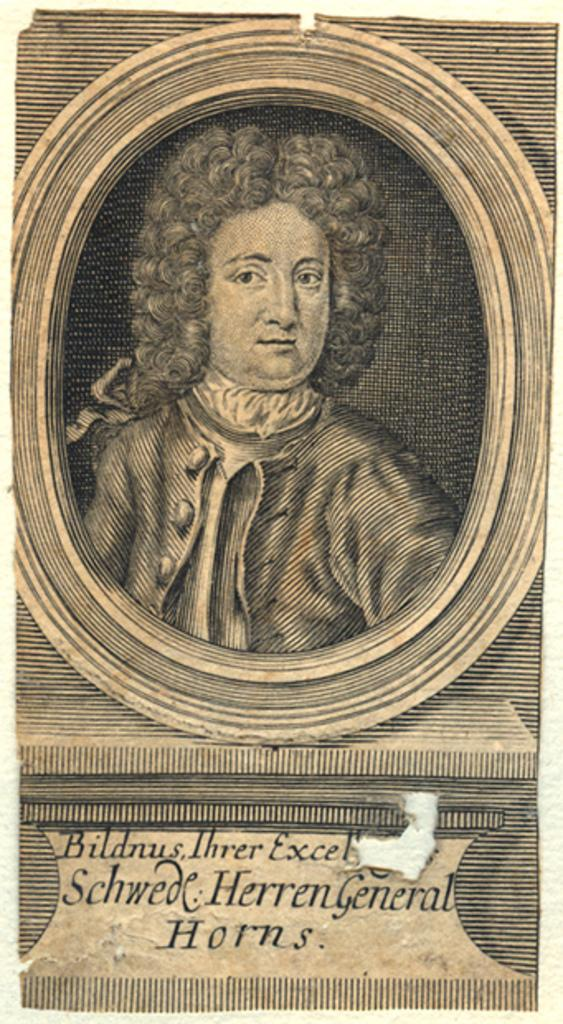<image>
Create a compact narrative representing the image presented. Picture of victorian era person titled Schwde Herren General. 